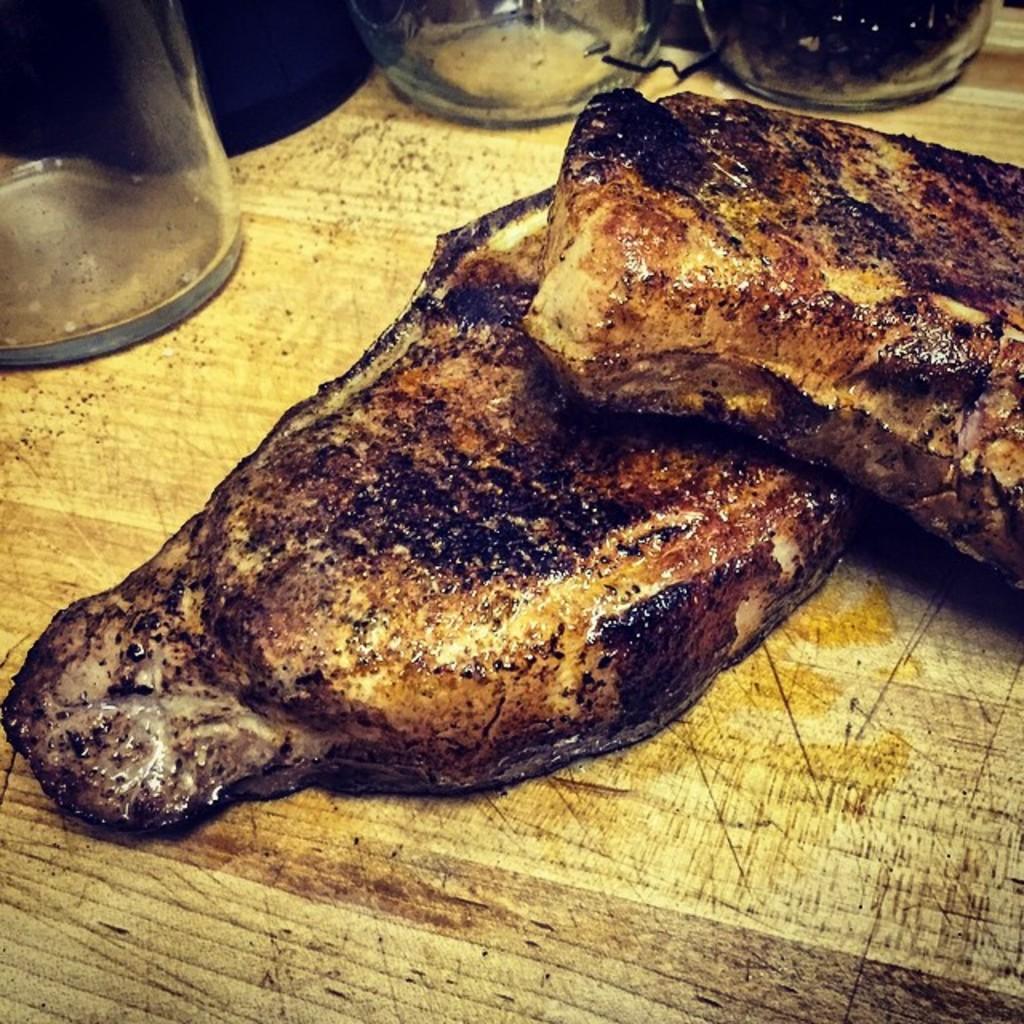Please provide a concise description of this image. In this image we can see food and group of glasses placed on the table. 